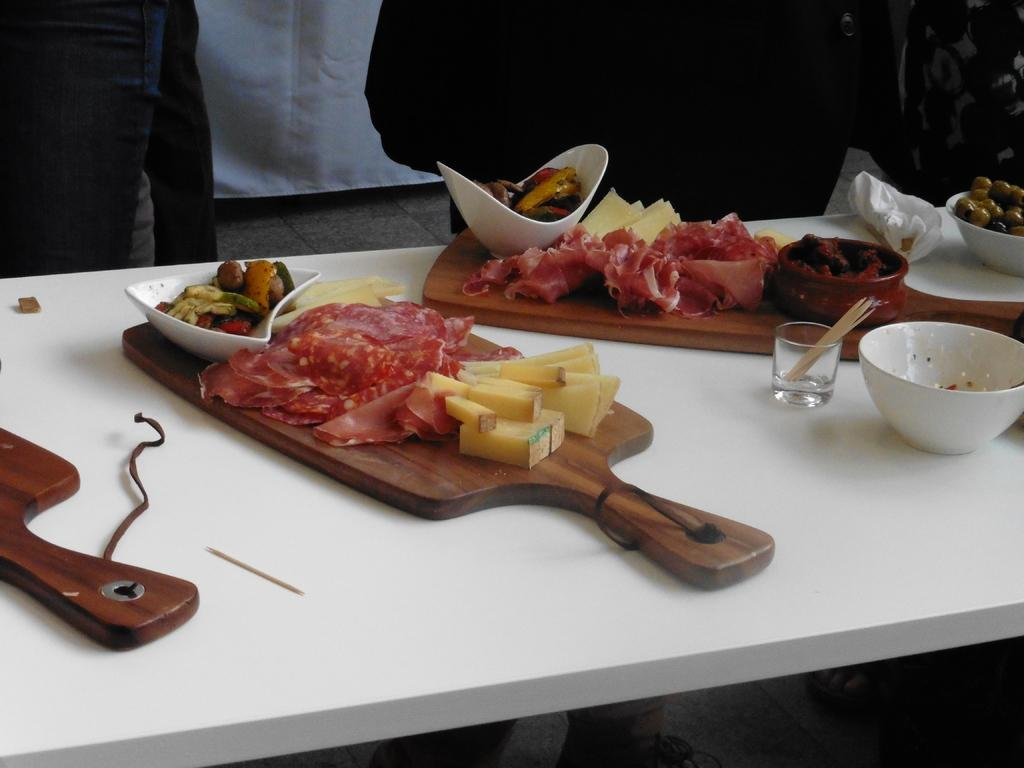What is the main object in the image? There is a table in the image. What can be found on the table? Different types of food are presented on the table. What type of question is being asked by the lawyer in the image? There is no lawyer or question being asked in the image; it only features a table with different types of food. 